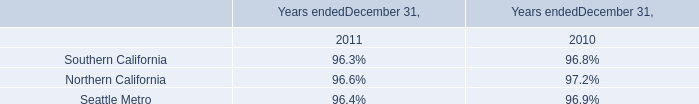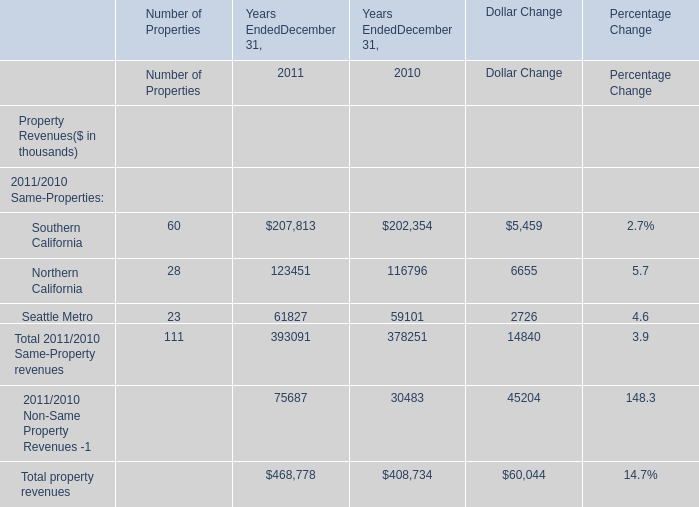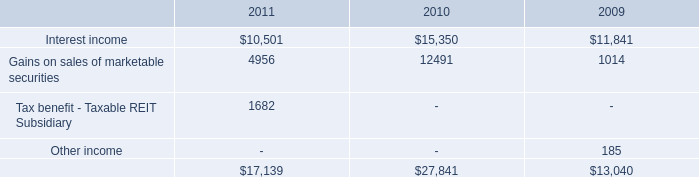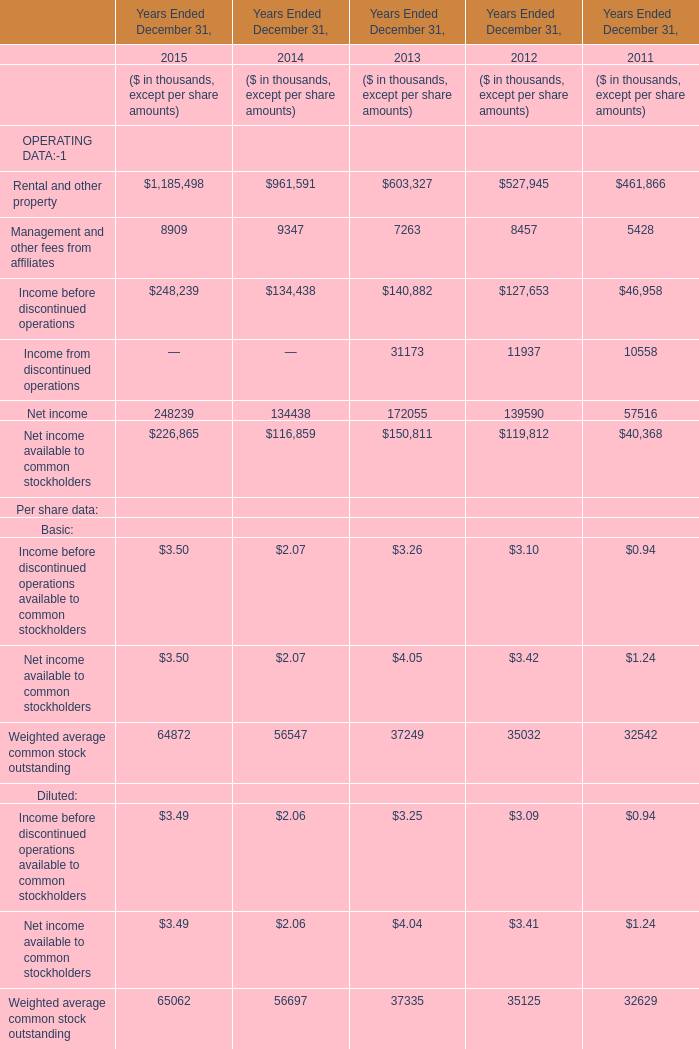What's the total amount of the Gains on sales of marketable securities in the years where Southern California for 2011/2010 Same-Properties for Years EndedDecember 31, is greater than 0? 
Computations: (4956 + 12491)
Answer: 17447.0. 